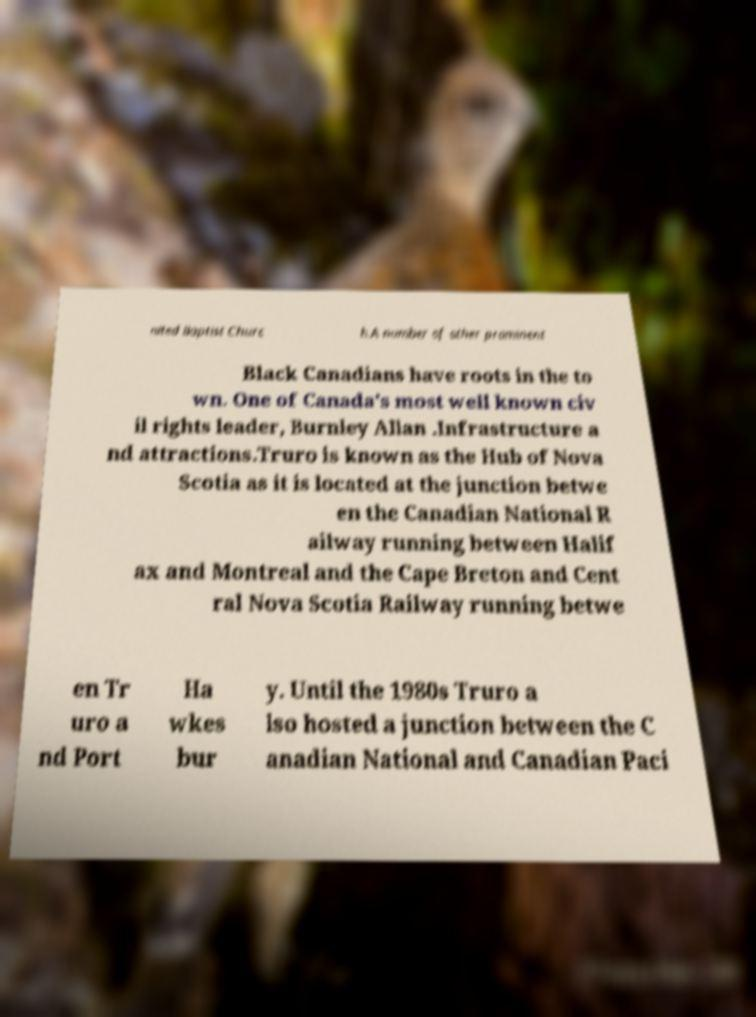Could you extract and type out the text from this image? nited Baptist Churc h.A number of other prominent Black Canadians have roots in the to wn. One of Canada's most well known civ il rights leader, Burnley Allan .Infrastructure a nd attractions.Truro is known as the Hub of Nova Scotia as it is located at the junction betwe en the Canadian National R ailway running between Halif ax and Montreal and the Cape Breton and Cent ral Nova Scotia Railway running betwe en Tr uro a nd Port Ha wkes bur y. Until the 1980s Truro a lso hosted a junction between the C anadian National and Canadian Paci 